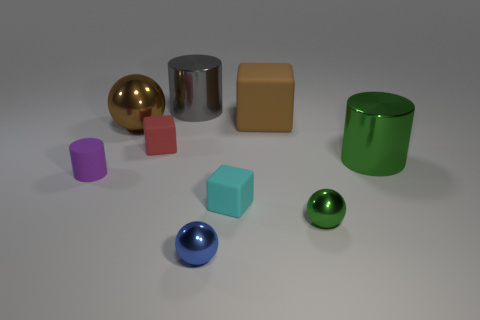Subtract all cylinders. How many objects are left? 6 Add 4 big metallic cylinders. How many big metallic cylinders exist? 6 Subtract 0 blue cylinders. How many objects are left? 9 Subtract all cyan spheres. Subtract all big brown rubber things. How many objects are left? 8 Add 8 large cylinders. How many large cylinders are left? 10 